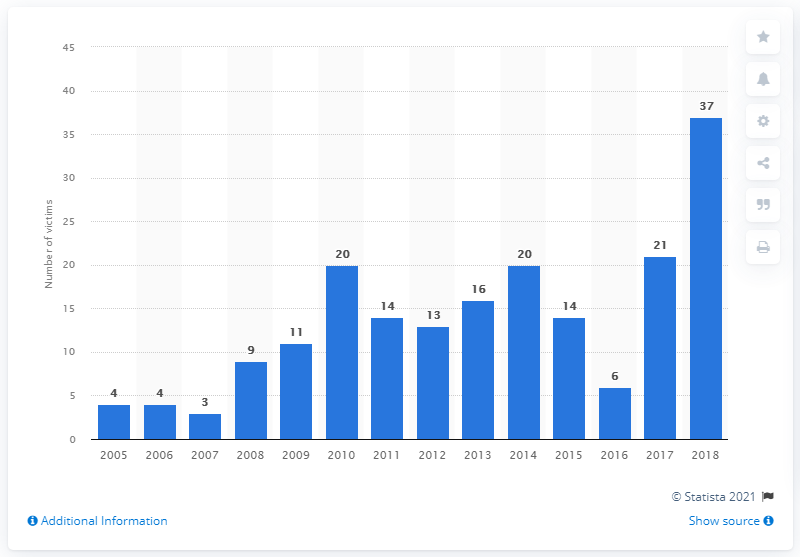What might be the societal impact of such high rates of violence against political figures? High rates of violence against political figures can significantly undermine political stability and public trust in governmental institutions. It might deter qualified individuals from entering politics, and can escalate fear and unrest among the populace. 